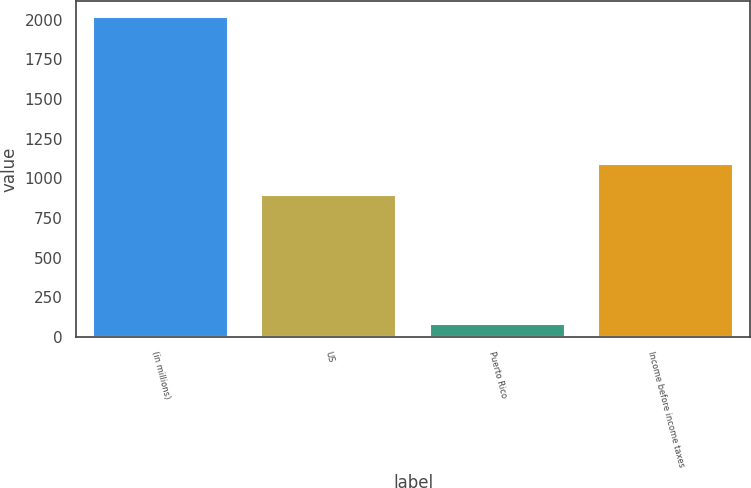Convert chart. <chart><loc_0><loc_0><loc_500><loc_500><bar_chart><fcel>(in millions)<fcel>US<fcel>Puerto Rico<fcel>Income before income taxes<nl><fcel>2015<fcel>898<fcel>80<fcel>1091.5<nl></chart> 